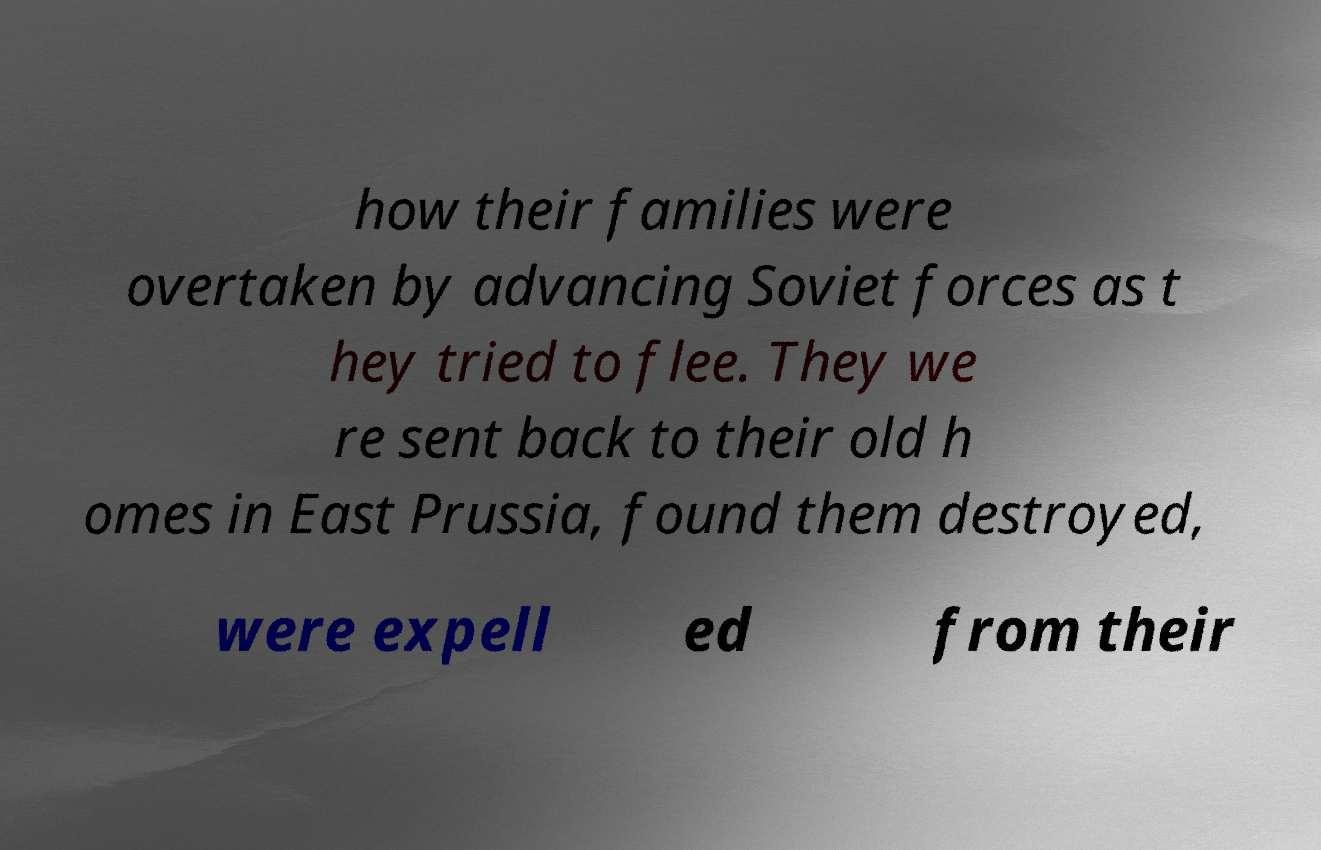For documentation purposes, I need the text within this image transcribed. Could you provide that? how their families were overtaken by advancing Soviet forces as t hey tried to flee. They we re sent back to their old h omes in East Prussia, found them destroyed, were expell ed from their 